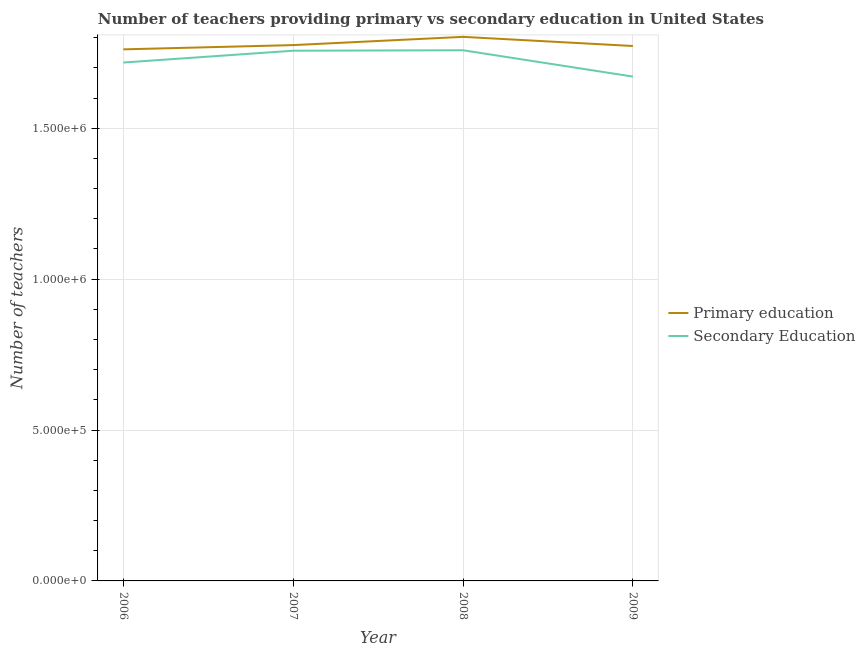How many different coloured lines are there?
Provide a succinct answer. 2. Is the number of lines equal to the number of legend labels?
Ensure brevity in your answer.  Yes. What is the number of secondary teachers in 2006?
Ensure brevity in your answer.  1.72e+06. Across all years, what is the maximum number of primary teachers?
Your answer should be very brief. 1.80e+06. Across all years, what is the minimum number of secondary teachers?
Keep it short and to the point. 1.67e+06. What is the total number of primary teachers in the graph?
Offer a very short reply. 7.11e+06. What is the difference between the number of secondary teachers in 2008 and that in 2009?
Provide a short and direct response. 8.72e+04. What is the difference between the number of secondary teachers in 2006 and the number of primary teachers in 2007?
Your answer should be very brief. -5.78e+04. What is the average number of primary teachers per year?
Offer a very short reply. 1.78e+06. In the year 2006, what is the difference between the number of primary teachers and number of secondary teachers?
Keep it short and to the point. 4.37e+04. In how many years, is the number of primary teachers greater than 300000?
Keep it short and to the point. 4. What is the ratio of the number of primary teachers in 2006 to that in 2009?
Ensure brevity in your answer.  0.99. Is the difference between the number of primary teachers in 2008 and 2009 greater than the difference between the number of secondary teachers in 2008 and 2009?
Ensure brevity in your answer.  No. What is the difference between the highest and the second highest number of secondary teachers?
Ensure brevity in your answer.  1516. What is the difference between the highest and the lowest number of secondary teachers?
Offer a terse response. 8.72e+04. In how many years, is the number of secondary teachers greater than the average number of secondary teachers taken over all years?
Offer a very short reply. 2. Is the number of secondary teachers strictly greater than the number of primary teachers over the years?
Provide a succinct answer. No. Is the number of secondary teachers strictly less than the number of primary teachers over the years?
Your response must be concise. Yes. How many lines are there?
Provide a succinct answer. 2. How many years are there in the graph?
Provide a short and direct response. 4. What is the difference between two consecutive major ticks on the Y-axis?
Give a very brief answer. 5.00e+05. Where does the legend appear in the graph?
Provide a short and direct response. Center right. How are the legend labels stacked?
Your answer should be compact. Vertical. What is the title of the graph?
Your answer should be compact. Number of teachers providing primary vs secondary education in United States. What is the label or title of the X-axis?
Provide a short and direct response. Year. What is the label or title of the Y-axis?
Keep it short and to the point. Number of teachers. What is the Number of teachers of Primary education in 2006?
Offer a very short reply. 1.76e+06. What is the Number of teachers of Secondary Education in 2006?
Give a very brief answer. 1.72e+06. What is the Number of teachers of Primary education in 2007?
Your response must be concise. 1.78e+06. What is the Number of teachers in Secondary Education in 2007?
Provide a short and direct response. 1.76e+06. What is the Number of teachers of Primary education in 2008?
Provide a succinct answer. 1.80e+06. What is the Number of teachers in Secondary Education in 2008?
Provide a short and direct response. 1.76e+06. What is the Number of teachers in Primary education in 2009?
Your response must be concise. 1.77e+06. What is the Number of teachers of Secondary Education in 2009?
Keep it short and to the point. 1.67e+06. Across all years, what is the maximum Number of teachers of Primary education?
Give a very brief answer. 1.80e+06. Across all years, what is the maximum Number of teachers in Secondary Education?
Provide a short and direct response. 1.76e+06. Across all years, what is the minimum Number of teachers in Primary education?
Ensure brevity in your answer.  1.76e+06. Across all years, what is the minimum Number of teachers in Secondary Education?
Offer a terse response. 1.67e+06. What is the total Number of teachers in Primary education in the graph?
Ensure brevity in your answer.  7.11e+06. What is the total Number of teachers in Secondary Education in the graph?
Offer a very short reply. 6.90e+06. What is the difference between the Number of teachers of Primary education in 2006 and that in 2007?
Offer a very short reply. -1.41e+04. What is the difference between the Number of teachers in Secondary Education in 2006 and that in 2007?
Give a very brief answer. -3.92e+04. What is the difference between the Number of teachers in Primary education in 2006 and that in 2008?
Offer a very short reply. -4.14e+04. What is the difference between the Number of teachers in Secondary Education in 2006 and that in 2008?
Your answer should be very brief. -4.07e+04. What is the difference between the Number of teachers in Primary education in 2006 and that in 2009?
Offer a very short reply. -1.11e+04. What is the difference between the Number of teachers of Secondary Education in 2006 and that in 2009?
Keep it short and to the point. 4.65e+04. What is the difference between the Number of teachers in Primary education in 2007 and that in 2008?
Offer a terse response. -2.73e+04. What is the difference between the Number of teachers of Secondary Education in 2007 and that in 2008?
Keep it short and to the point. -1516. What is the difference between the Number of teachers in Primary education in 2007 and that in 2009?
Your answer should be very brief. 2998. What is the difference between the Number of teachers of Secondary Education in 2007 and that in 2009?
Keep it short and to the point. 8.57e+04. What is the difference between the Number of teachers in Primary education in 2008 and that in 2009?
Keep it short and to the point. 3.03e+04. What is the difference between the Number of teachers of Secondary Education in 2008 and that in 2009?
Offer a terse response. 8.72e+04. What is the difference between the Number of teachers of Primary education in 2006 and the Number of teachers of Secondary Education in 2007?
Give a very brief answer. 4491. What is the difference between the Number of teachers of Primary education in 2006 and the Number of teachers of Secondary Education in 2008?
Your answer should be very brief. 2975. What is the difference between the Number of teachers in Primary education in 2006 and the Number of teachers in Secondary Education in 2009?
Your response must be concise. 9.02e+04. What is the difference between the Number of teachers in Primary education in 2007 and the Number of teachers in Secondary Education in 2008?
Your response must be concise. 1.71e+04. What is the difference between the Number of teachers of Primary education in 2007 and the Number of teachers of Secondary Education in 2009?
Keep it short and to the point. 1.04e+05. What is the difference between the Number of teachers in Primary education in 2008 and the Number of teachers in Secondary Education in 2009?
Provide a succinct answer. 1.32e+05. What is the average Number of teachers of Primary education per year?
Make the answer very short. 1.78e+06. What is the average Number of teachers of Secondary Education per year?
Ensure brevity in your answer.  1.73e+06. In the year 2006, what is the difference between the Number of teachers of Primary education and Number of teachers of Secondary Education?
Offer a very short reply. 4.37e+04. In the year 2007, what is the difference between the Number of teachers of Primary education and Number of teachers of Secondary Education?
Provide a short and direct response. 1.86e+04. In the year 2008, what is the difference between the Number of teachers in Primary education and Number of teachers in Secondary Education?
Your answer should be very brief. 4.44e+04. In the year 2009, what is the difference between the Number of teachers of Primary education and Number of teachers of Secondary Education?
Your response must be concise. 1.01e+05. What is the ratio of the Number of teachers of Primary education in 2006 to that in 2007?
Offer a very short reply. 0.99. What is the ratio of the Number of teachers of Secondary Education in 2006 to that in 2007?
Your response must be concise. 0.98. What is the ratio of the Number of teachers of Primary education in 2006 to that in 2008?
Provide a short and direct response. 0.98. What is the ratio of the Number of teachers in Secondary Education in 2006 to that in 2008?
Offer a very short reply. 0.98. What is the ratio of the Number of teachers in Primary education in 2006 to that in 2009?
Give a very brief answer. 0.99. What is the ratio of the Number of teachers of Secondary Education in 2006 to that in 2009?
Your answer should be compact. 1.03. What is the ratio of the Number of teachers of Primary education in 2007 to that in 2008?
Provide a short and direct response. 0.98. What is the ratio of the Number of teachers in Secondary Education in 2007 to that in 2008?
Offer a very short reply. 1. What is the ratio of the Number of teachers of Primary education in 2007 to that in 2009?
Give a very brief answer. 1. What is the ratio of the Number of teachers of Secondary Education in 2007 to that in 2009?
Give a very brief answer. 1.05. What is the ratio of the Number of teachers of Primary education in 2008 to that in 2009?
Provide a succinct answer. 1.02. What is the ratio of the Number of teachers of Secondary Education in 2008 to that in 2009?
Keep it short and to the point. 1.05. What is the difference between the highest and the second highest Number of teachers of Primary education?
Keep it short and to the point. 2.73e+04. What is the difference between the highest and the second highest Number of teachers of Secondary Education?
Offer a terse response. 1516. What is the difference between the highest and the lowest Number of teachers in Primary education?
Ensure brevity in your answer.  4.14e+04. What is the difference between the highest and the lowest Number of teachers in Secondary Education?
Your answer should be compact. 8.72e+04. 